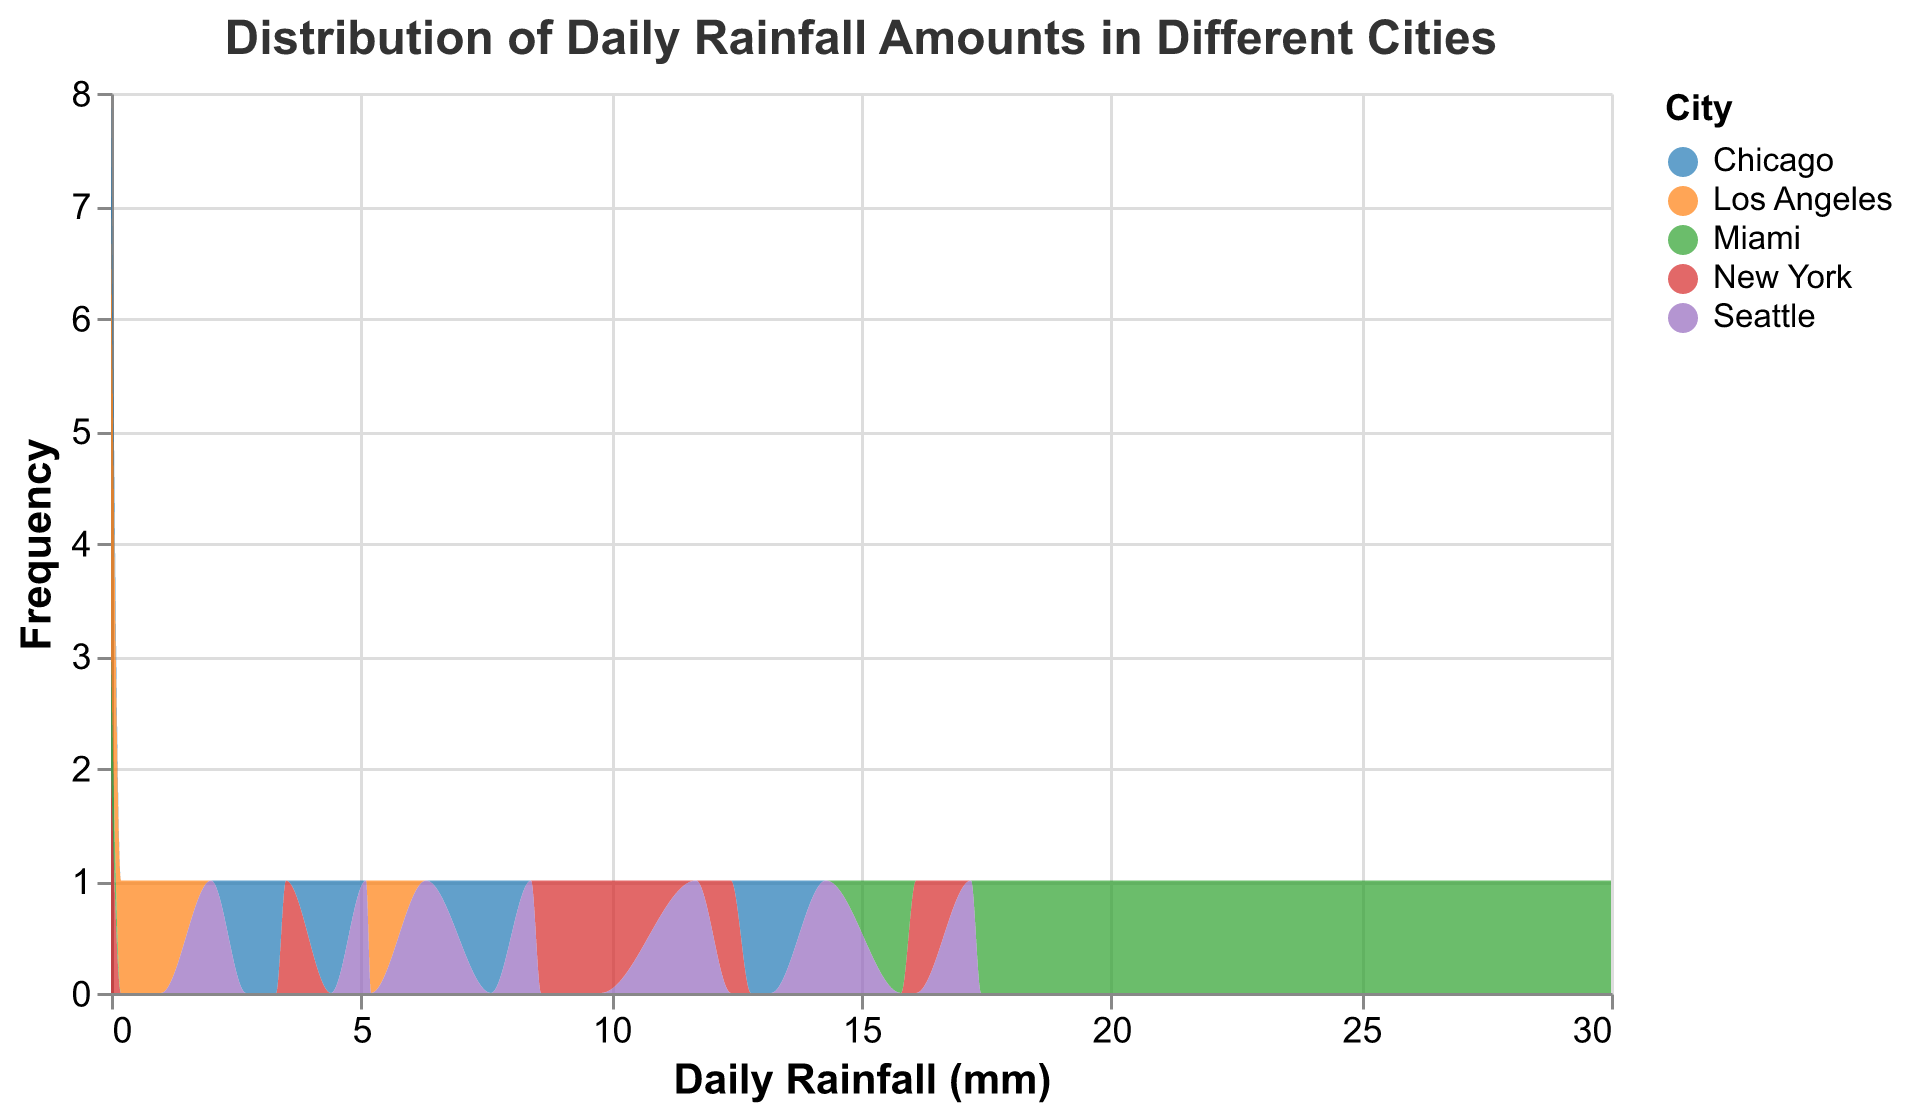What is the title of the figure? The title of the figure is prominently displayed at the top and is "Distribution of Daily Rainfall Amounts in Different Cities".
Answer: Distribution of Daily Rainfall Amounts in Different Cities How many cities are represented in the figure? The legend of the figure shows different color codes for each city, which we can count to determine the number of cities.
Answer: 5 Which city has the highest frequency of daily rainfall above 20 mm? We need to look at the part of the figure where the daily rainfall is above 20 mm and find which city's color appears most frequently in that range. Miami shows the highest frequency in this range.
Answer: Miami Which city has the most days with no rainfall? Identify the section of the figure where the daily rainfall is 0 mm and count the occurrences for each color representing a city. New York and Los Angeles both have multiple days with no rainfall, but New York and Miami have the precise days recorded.
Answer: Los Angeles Which city has the widest spread of daily rainfall amounts? Observe the horizontal spread of each city's color in the figure. Miami spans a wide range from 0 mm to 30 mm while Los Angeles has a much smaller range.
Answer: Miami What is the average daily rainfall amount for Seattle? Calculate the average of Seattle's daily rainfall amounts. Adding the values (5.1 + 6.3 + 8.4 + 17.2 + 11.7 + 14.3 + 2.0) gives 65.0 mm, and dividing by 7 days: \( \frac{65.0}{7} \approx 9.3 \) mm.
Answer: 9.3 mm Compare the frequency of daily rainfall between 0-5 mm for New York and Los Angeles. Look at the segments of the figure representing 0-5 mm and compare the heights of the curves for New York (blue) and Los Angeles (orange).
Answer: New York has a higher frequency Which city experiences consistent daily rainfall throughout the week? Observe the figure to see which city has its color spanning across almost every day within a consistent range, indicating steadiness. Seattle appears to have a consistent range daily.
Answer: Seattle 